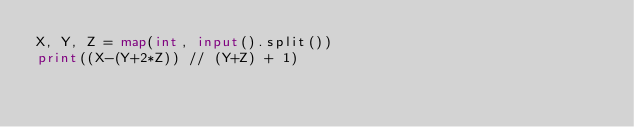Convert code to text. <code><loc_0><loc_0><loc_500><loc_500><_Python_>X, Y, Z = map(int, input().split())
print((X-(Y+2*Z)) // (Y+Z) + 1)</code> 